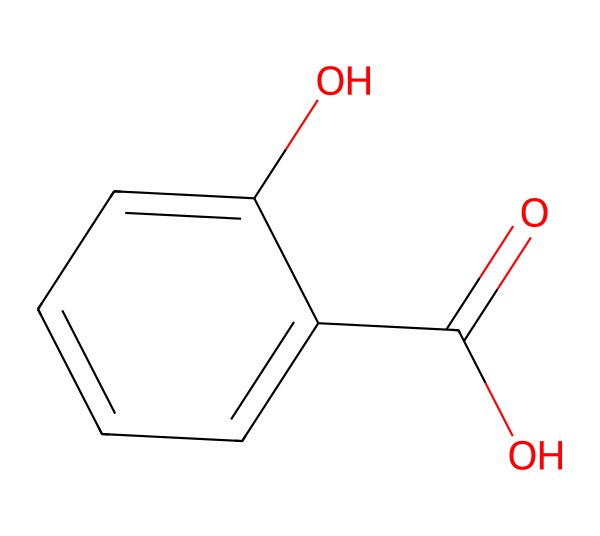What is the name of this chemical? The structure corresponds to a well-known compound used in skincare, recognized for its beneficial properties. Analyzing its functional groups and structure leads us to identify it as salicylic acid.
Answer: salicylic acid How many carbon atoms are present in the structure? By examining the structure, we count the number of carbon atoms. The structure shows a benzene ring and the acid group, totaling 7 carbon atoms.
Answer: 7 What functional group is present in salicylic acid? The chemical structure shows a carboxylic acid group (-COOH) as well as a hydroxyl group (-OH). The presence of the -COOH group indicates that it is a carboxylic acid.
Answer: carboxylic acid How many oxygen atoms are present in the structure? Looking at the chemical formula, we can identify two oxygen atoms: one in the carboxylic acid group and the other in the hydroxyl group.
Answer: 2 What kind of properties does salicylic acid exhibit due to its acidity? The presence of the carboxylic acid group in the structure gives salicylic acid its acidic properties, leading to characteristics such as exfoliation and anti-inflammatory effects.
Answer: exfoliating What type of chemical is salicylic acid classified as? Given that it contains a carboxylic acid functional group and displays acidic behavior, it can be classified under organic acids, which often have applications in skincare.
Answer: organic acid Is salicylic acid soluble in water? The presence of both hydroxyl and carboxyl groups contributes to the polarity of salicylic acid, allowing it to dissolve in water due to hydrogen bonding.
Answer: yes 